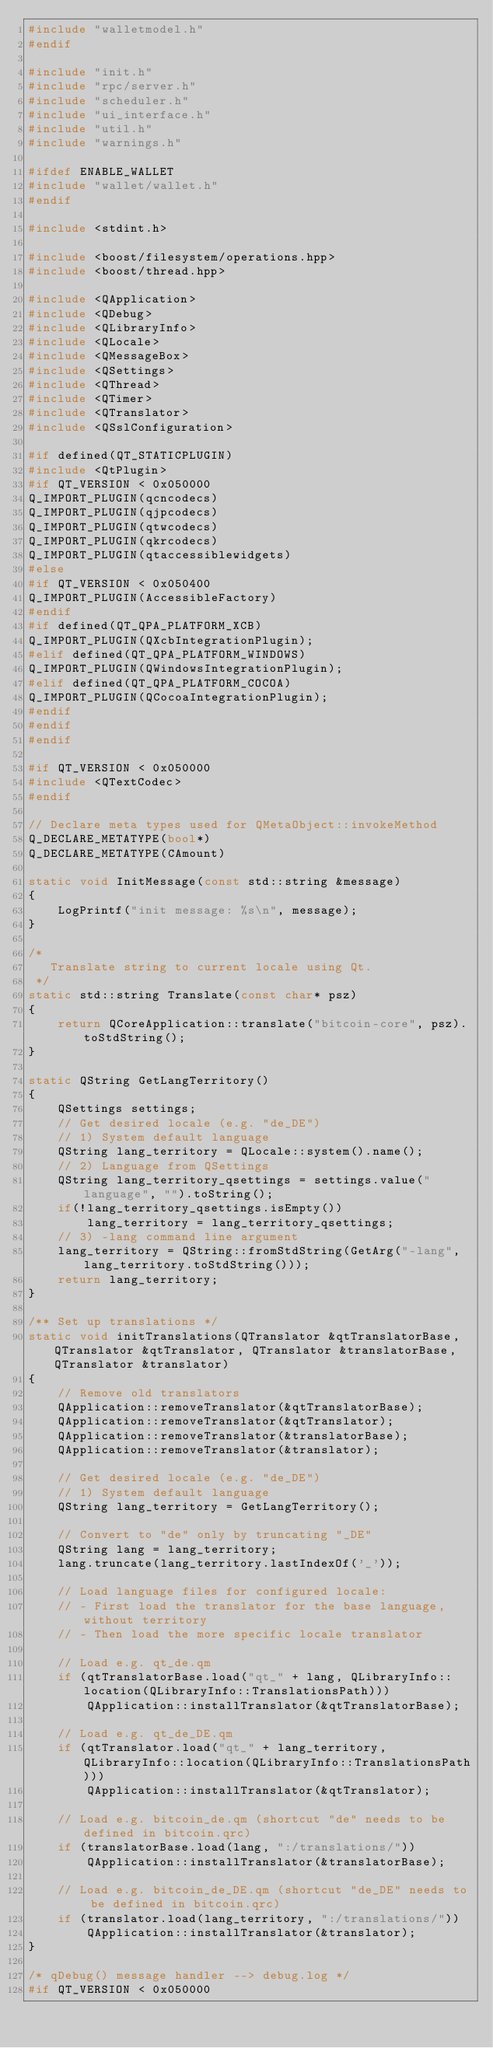<code> <loc_0><loc_0><loc_500><loc_500><_C++_>#include "walletmodel.h"
#endif

#include "init.h"
#include "rpc/server.h"
#include "scheduler.h"
#include "ui_interface.h"
#include "util.h"
#include "warnings.h"

#ifdef ENABLE_WALLET
#include "wallet/wallet.h"
#endif

#include <stdint.h>

#include <boost/filesystem/operations.hpp>
#include <boost/thread.hpp>

#include <QApplication>
#include <QDebug>
#include <QLibraryInfo>
#include <QLocale>
#include <QMessageBox>
#include <QSettings>
#include <QThread>
#include <QTimer>
#include <QTranslator>
#include <QSslConfiguration>

#if defined(QT_STATICPLUGIN)
#include <QtPlugin>
#if QT_VERSION < 0x050000
Q_IMPORT_PLUGIN(qcncodecs)
Q_IMPORT_PLUGIN(qjpcodecs)
Q_IMPORT_PLUGIN(qtwcodecs)
Q_IMPORT_PLUGIN(qkrcodecs)
Q_IMPORT_PLUGIN(qtaccessiblewidgets)
#else
#if QT_VERSION < 0x050400
Q_IMPORT_PLUGIN(AccessibleFactory)
#endif
#if defined(QT_QPA_PLATFORM_XCB)
Q_IMPORT_PLUGIN(QXcbIntegrationPlugin);
#elif defined(QT_QPA_PLATFORM_WINDOWS)
Q_IMPORT_PLUGIN(QWindowsIntegrationPlugin);
#elif defined(QT_QPA_PLATFORM_COCOA)
Q_IMPORT_PLUGIN(QCocoaIntegrationPlugin);
#endif
#endif
#endif

#if QT_VERSION < 0x050000
#include <QTextCodec>
#endif

// Declare meta types used for QMetaObject::invokeMethod
Q_DECLARE_METATYPE(bool*)
Q_DECLARE_METATYPE(CAmount)

static void InitMessage(const std::string &message)
{
    LogPrintf("init message: %s\n", message);
}

/*
   Translate string to current locale using Qt.
 */
static std::string Translate(const char* psz)
{
    return QCoreApplication::translate("bitcoin-core", psz).toStdString();
}

static QString GetLangTerritory()
{
    QSettings settings;
    // Get desired locale (e.g. "de_DE")
    // 1) System default language
    QString lang_territory = QLocale::system().name();
    // 2) Language from QSettings
    QString lang_territory_qsettings = settings.value("language", "").toString();
    if(!lang_territory_qsettings.isEmpty())
        lang_territory = lang_territory_qsettings;
    // 3) -lang command line argument
    lang_territory = QString::fromStdString(GetArg("-lang", lang_territory.toStdString()));
    return lang_territory;
}

/** Set up translations */
static void initTranslations(QTranslator &qtTranslatorBase, QTranslator &qtTranslator, QTranslator &translatorBase, QTranslator &translator)
{
    // Remove old translators
    QApplication::removeTranslator(&qtTranslatorBase);
    QApplication::removeTranslator(&qtTranslator);
    QApplication::removeTranslator(&translatorBase);
    QApplication::removeTranslator(&translator);

    // Get desired locale (e.g. "de_DE")
    // 1) System default language
    QString lang_territory = GetLangTerritory();

    // Convert to "de" only by truncating "_DE"
    QString lang = lang_territory;
    lang.truncate(lang_territory.lastIndexOf('_'));

    // Load language files for configured locale:
    // - First load the translator for the base language, without territory
    // - Then load the more specific locale translator

    // Load e.g. qt_de.qm
    if (qtTranslatorBase.load("qt_" + lang, QLibraryInfo::location(QLibraryInfo::TranslationsPath)))
        QApplication::installTranslator(&qtTranslatorBase);

    // Load e.g. qt_de_DE.qm
    if (qtTranslator.load("qt_" + lang_territory, QLibraryInfo::location(QLibraryInfo::TranslationsPath)))
        QApplication::installTranslator(&qtTranslator);

    // Load e.g. bitcoin_de.qm (shortcut "de" needs to be defined in bitcoin.qrc)
    if (translatorBase.load(lang, ":/translations/"))
        QApplication::installTranslator(&translatorBase);

    // Load e.g. bitcoin_de_DE.qm (shortcut "de_DE" needs to be defined in bitcoin.qrc)
    if (translator.load(lang_territory, ":/translations/"))
        QApplication::installTranslator(&translator);
}

/* qDebug() message handler --> debug.log */
#if QT_VERSION < 0x050000</code> 